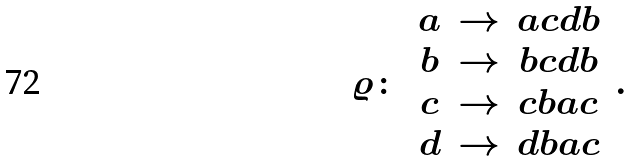<formula> <loc_0><loc_0><loc_500><loc_500>\varrho \colon \, \begin{array} { c c c } a & \to & a c d b \\ b & \to & b c d b \\ c & \to & c b a c \\ d & \to & d b a c \end{array} \, .</formula> 